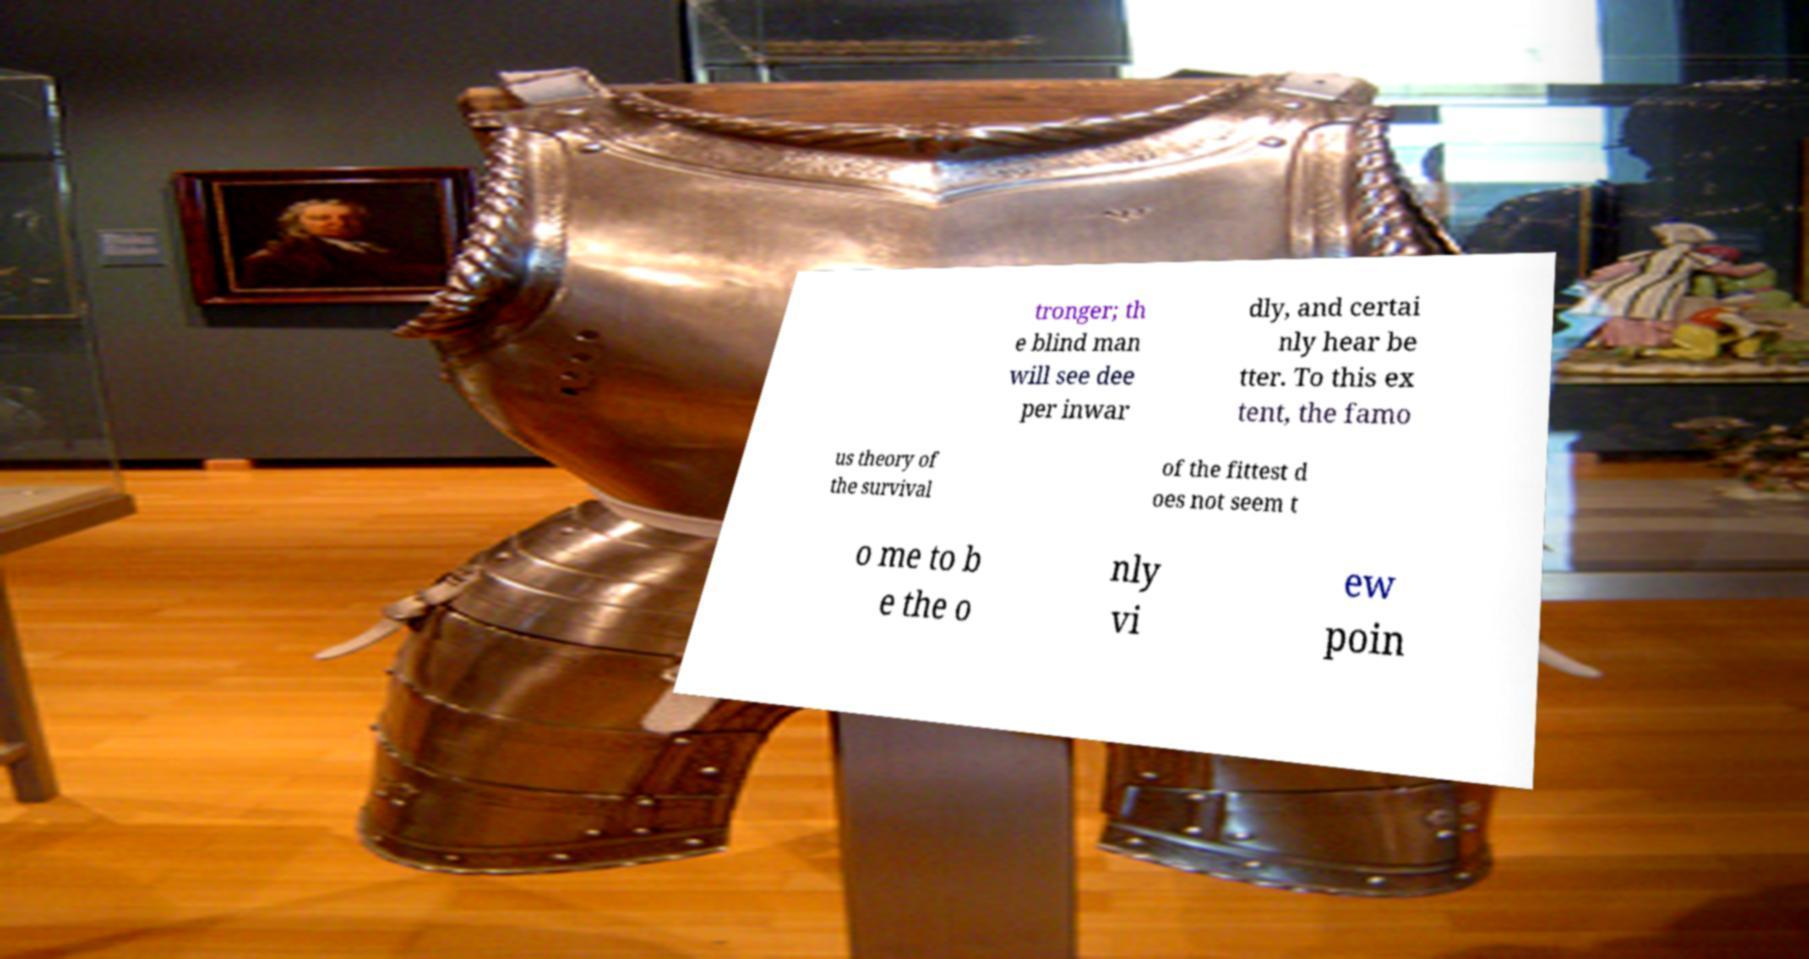Could you assist in decoding the text presented in this image and type it out clearly? tronger; th e blind man will see dee per inwar dly, and certai nly hear be tter. To this ex tent, the famo us theory of the survival of the fittest d oes not seem t o me to b e the o nly vi ew poin 